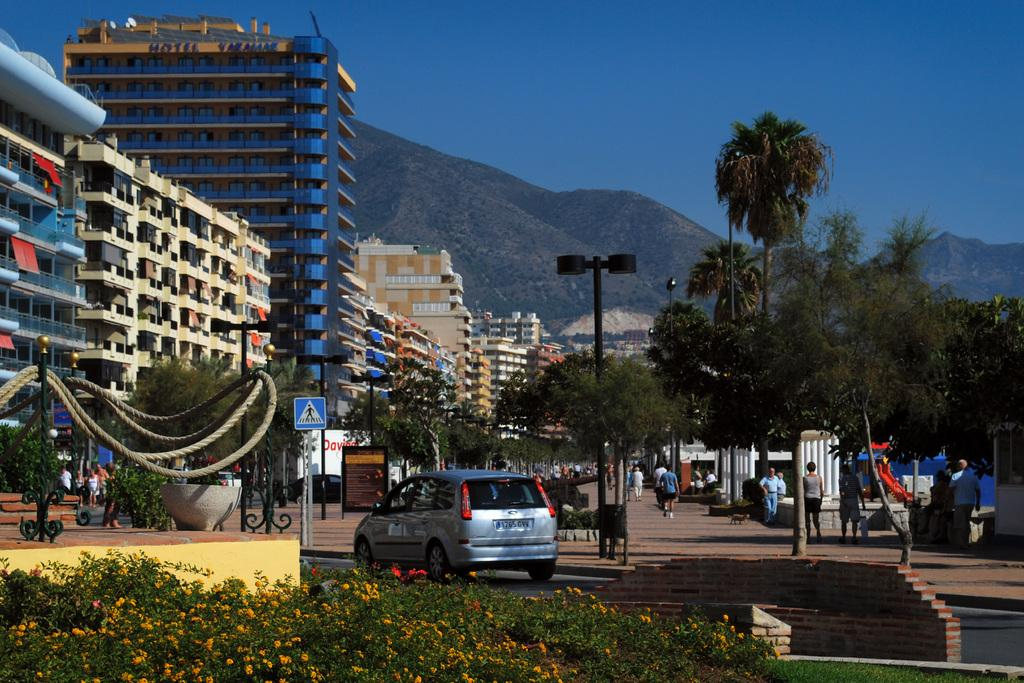What is the main subject of the image? There is a car in the image. What else can be seen in the image besides the car? There are plants, people walking on the road, a building, and trees in the image. How many cups of coffee are being held by the people walking on the road in the image? There is no mention of cups of coffee or people holding them in the image; only people walking on the road are mentioned. What type of bushes can be seen in the image? There is no mention of bushes in the image; only plants, trees, and a building are mentioned. 